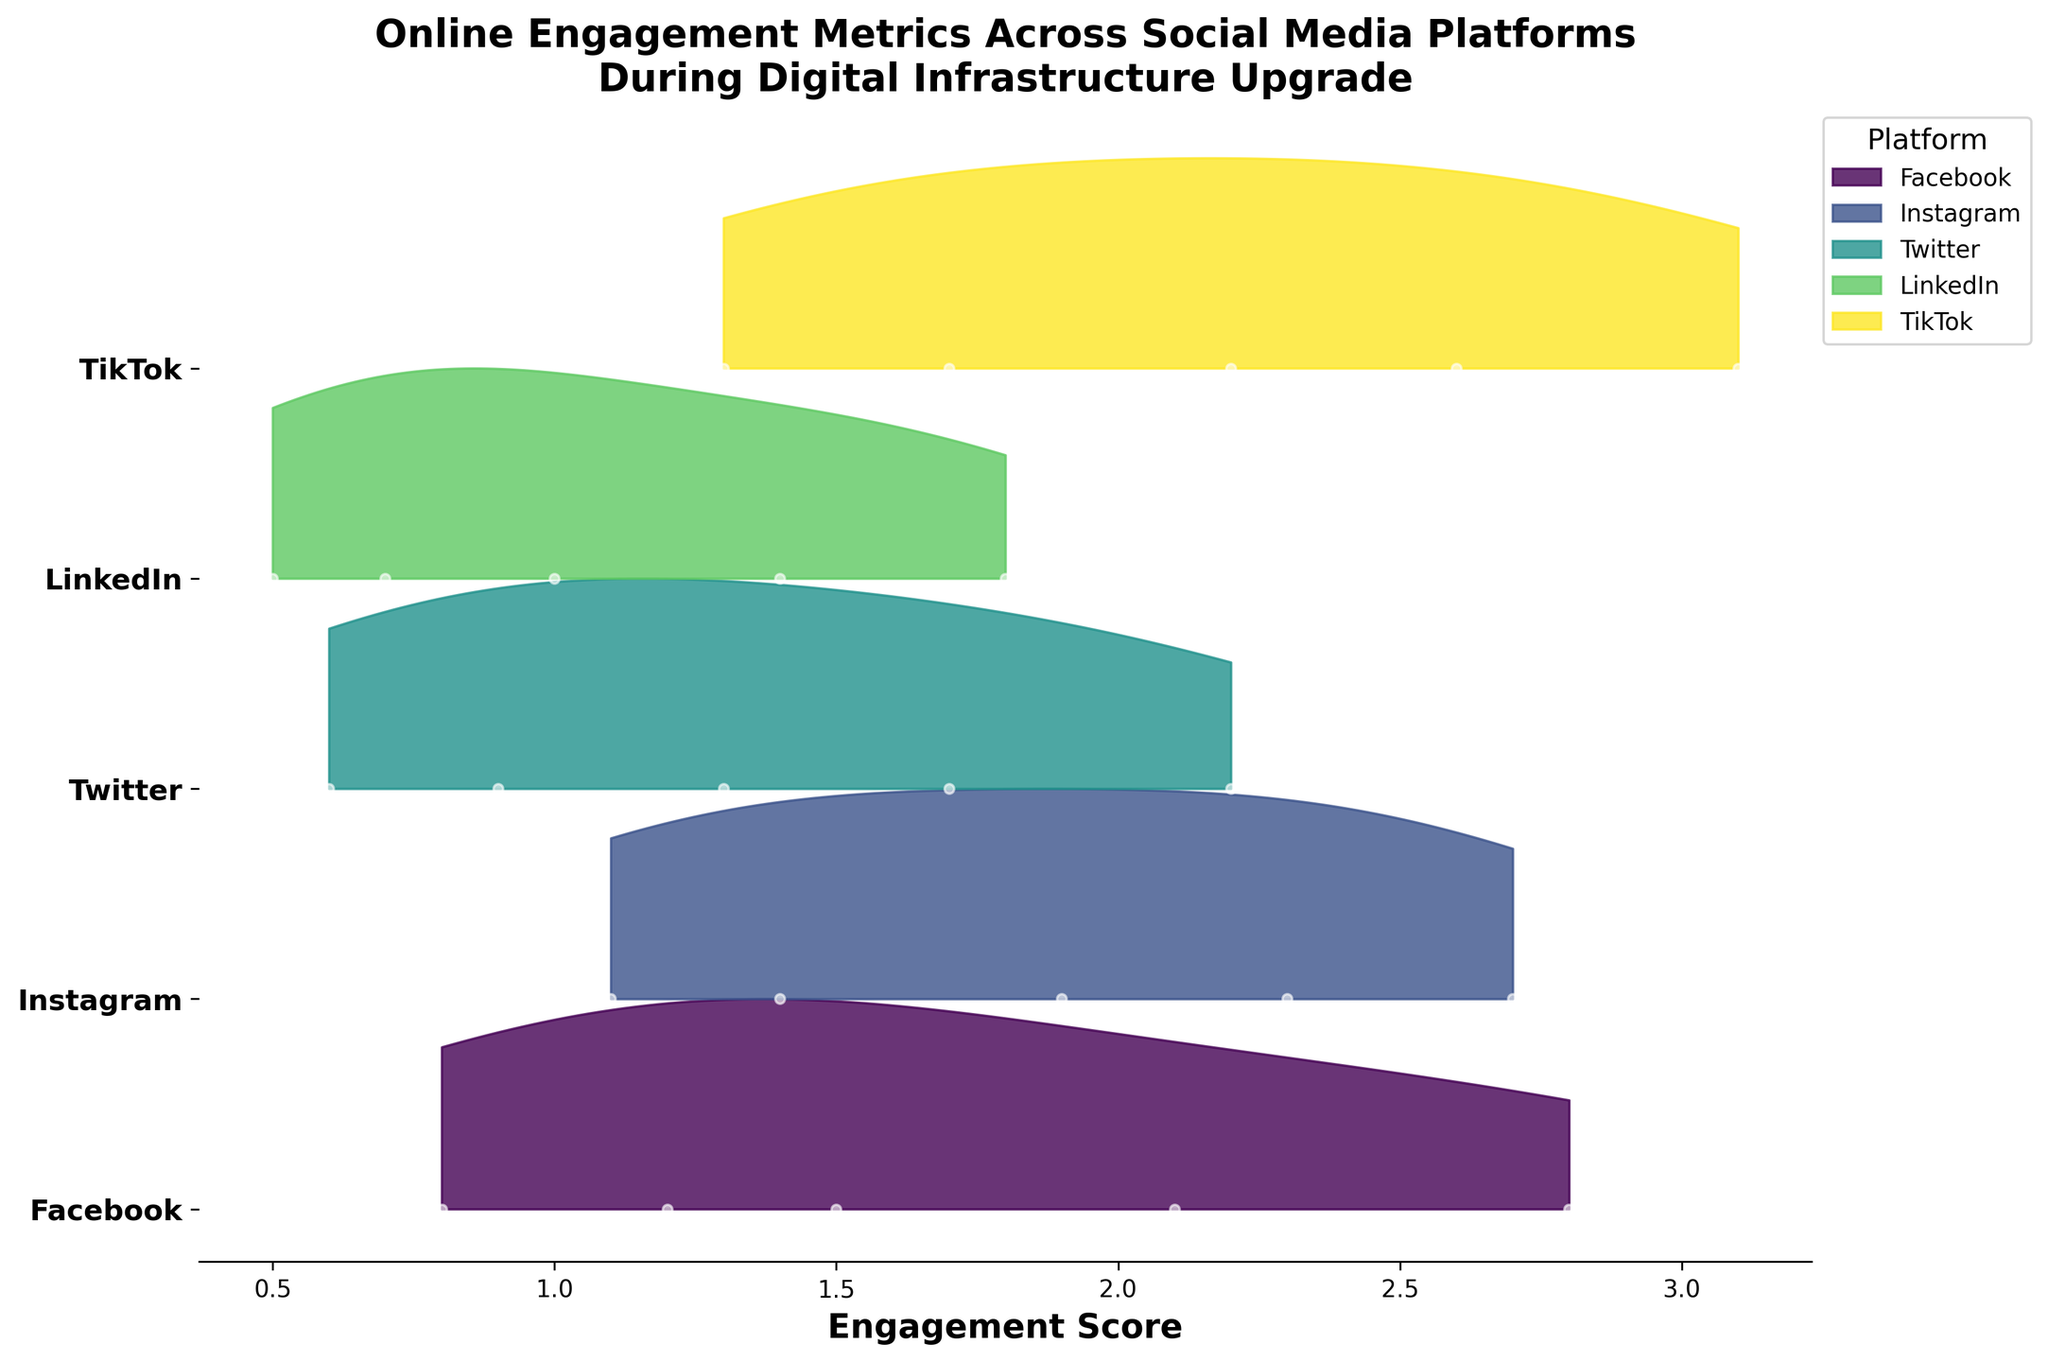What is the title of the plot? The title is usually found at the top of the plot and provides a summary of what the plot represents.
Answer: Online Engagement Metrics Across Social Media Platforms During Digital Infrastructure Upgrade Which platform shows the highest peak in engagement score in the 5th week? To find the platform with the highest peak, look for the highest engagement score at week 5 across platforms.
Answer: TikTok Are the engagement scores generally increasing or decreasing over time? Assess the overall trend of engagement scores from week 1 to week 5 for each platform.
Answer: Increasing Which platform has the lowest engagement score during the first week? Identify the engagement scores at week 1 and compare them across platforms.
Answer: LinkedIn How many platforms are compared in this plot? Count the unique platforms depicted in the plot.
Answer: 5 Between which weeks does Facebook show the largest increase in engagement score? Examine the differences in engagement scores between consecutive weeks for Facebook and find the largest.
Answer: Week 4 to Week 5 On which week does Twitter surpass an engagement score of 2? Locate the engagement scores for Twitter and identify the week when the score exceeds 2.
Answer: Week 5 Which platform has the smoothest increase in engagement scores over time? Compare the patterns of increase in engagements across platforms, looking for a steadily rising trend.
Answer: LinkedIn Based on the plot, which platform might be benefiting the most from the digital infrastructure upgrade? Consider which platform shows the highest overall increase in engagement scores during the upgrade period.
Answer: TikTok 